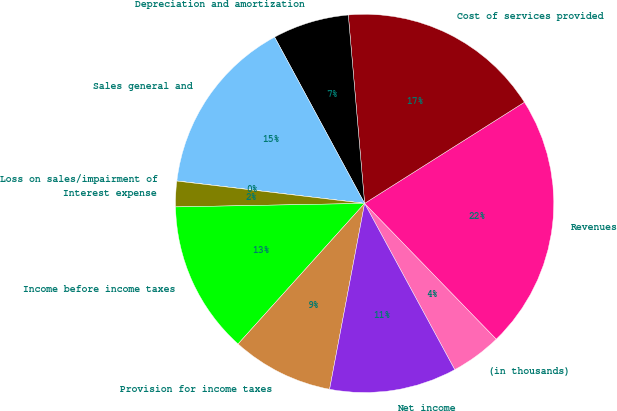Convert chart to OTSL. <chart><loc_0><loc_0><loc_500><loc_500><pie_chart><fcel>(in thousands)<fcel>Revenues<fcel>Cost of services provided<fcel>Depreciation and amortization<fcel>Sales general and<fcel>Loss on sales/impairment of<fcel>Interest expense<fcel>Income before income taxes<fcel>Provision for income taxes<fcel>Net income<nl><fcel>4.35%<fcel>21.73%<fcel>17.39%<fcel>6.52%<fcel>15.21%<fcel>0.01%<fcel>2.18%<fcel>13.04%<fcel>8.7%<fcel>10.87%<nl></chart> 